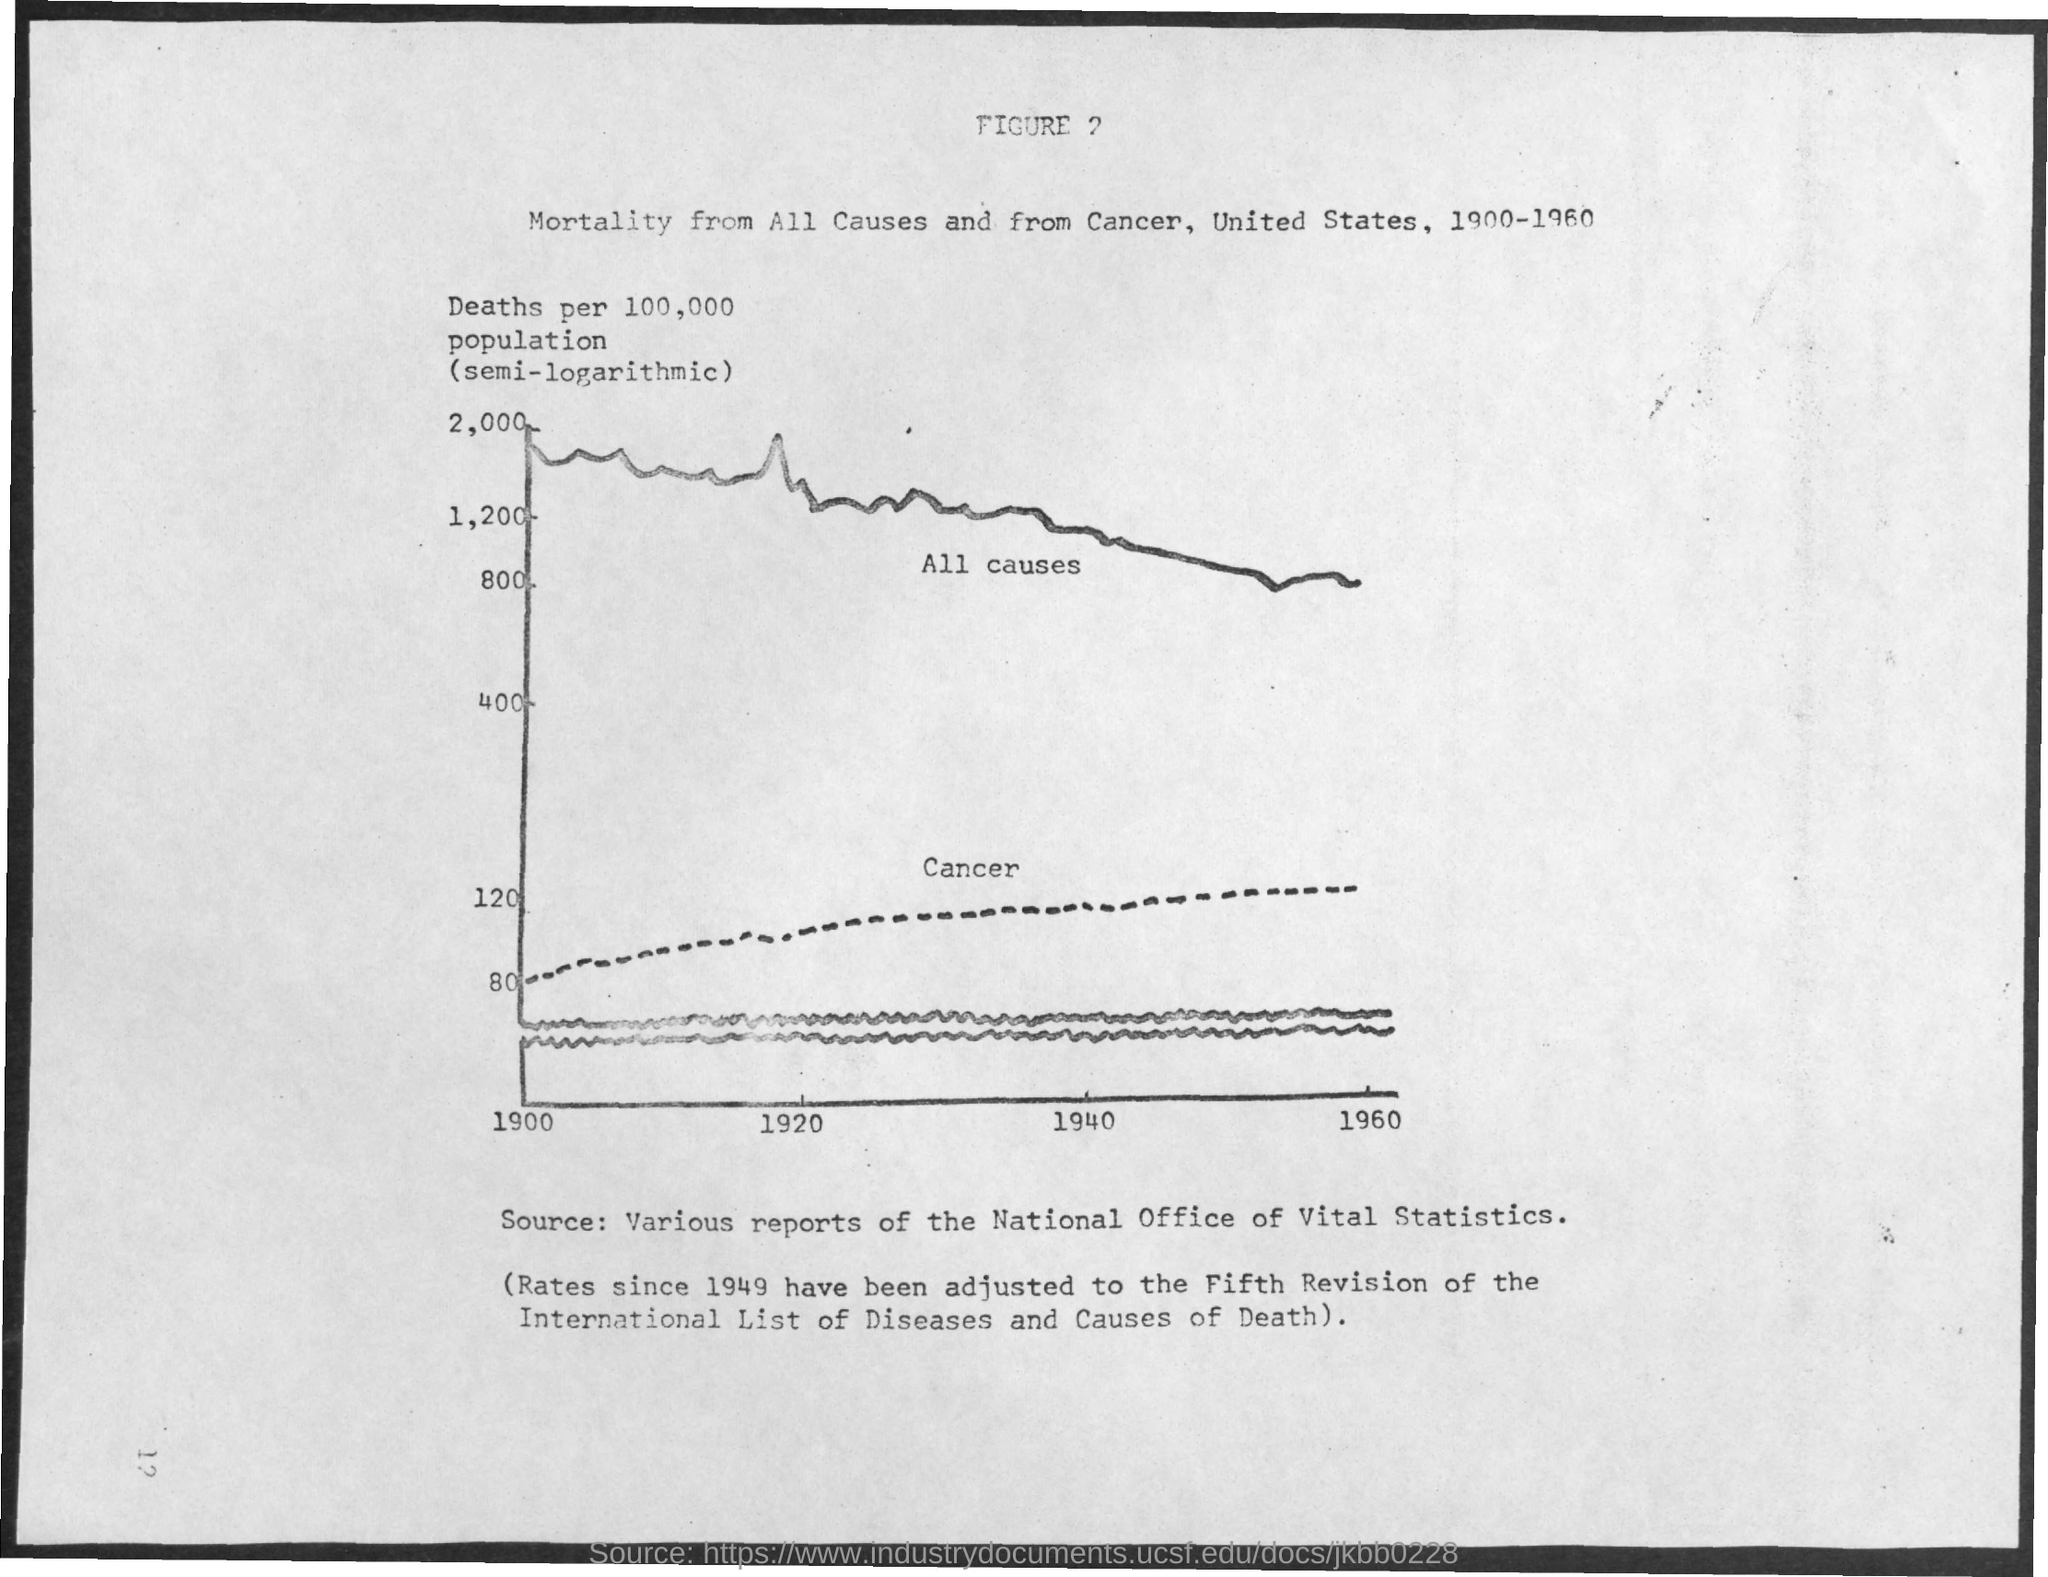Draw attention to some important aspects in this diagram. The number that is plotted last on the y-axis is 2,000. The question asks which year is represented last on the x-axis. The question asks which year is plotted first on the x-axis in a graph or chart with years 1900 and 2023. The dotted line represents the presence of cancer. The bold line denotes which disease. All causes are included. 